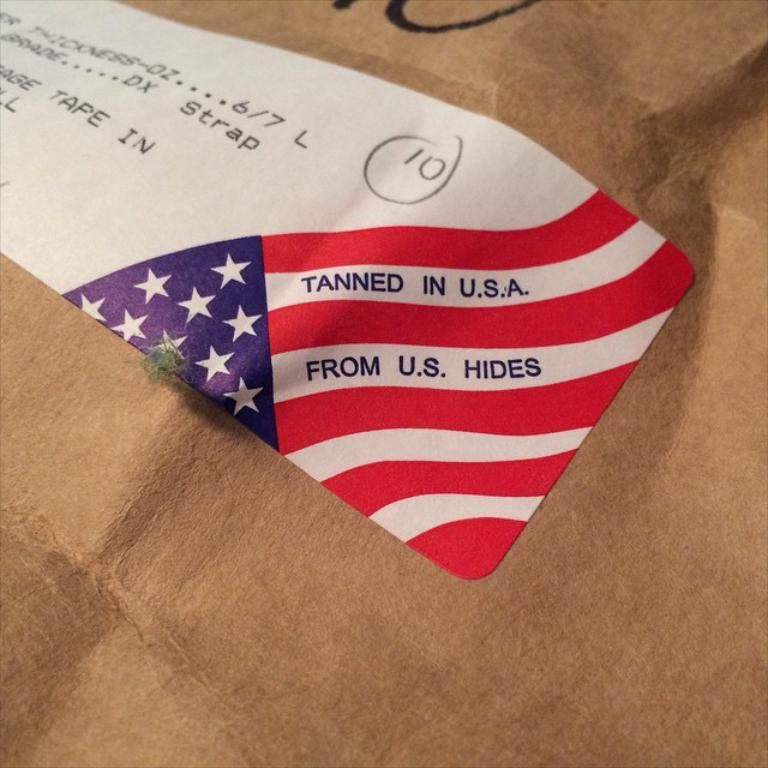<image>
Render a clear and concise summary of the photo. A label saying Tanned in the USA from US hides. 